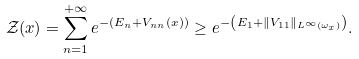<formula> <loc_0><loc_0><loc_500><loc_500>\mathcal { Z } ( x ) = \sum _ { n = 1 } ^ { + \infty } e ^ { - \left ( E _ { n } + V _ { n n } ( x ) \right ) } \geq e ^ { - \left ( E _ { 1 } + \| V _ { 1 1 } \| _ { L ^ { \infty } ( \omega _ { x } ) } \right ) } .</formula> 